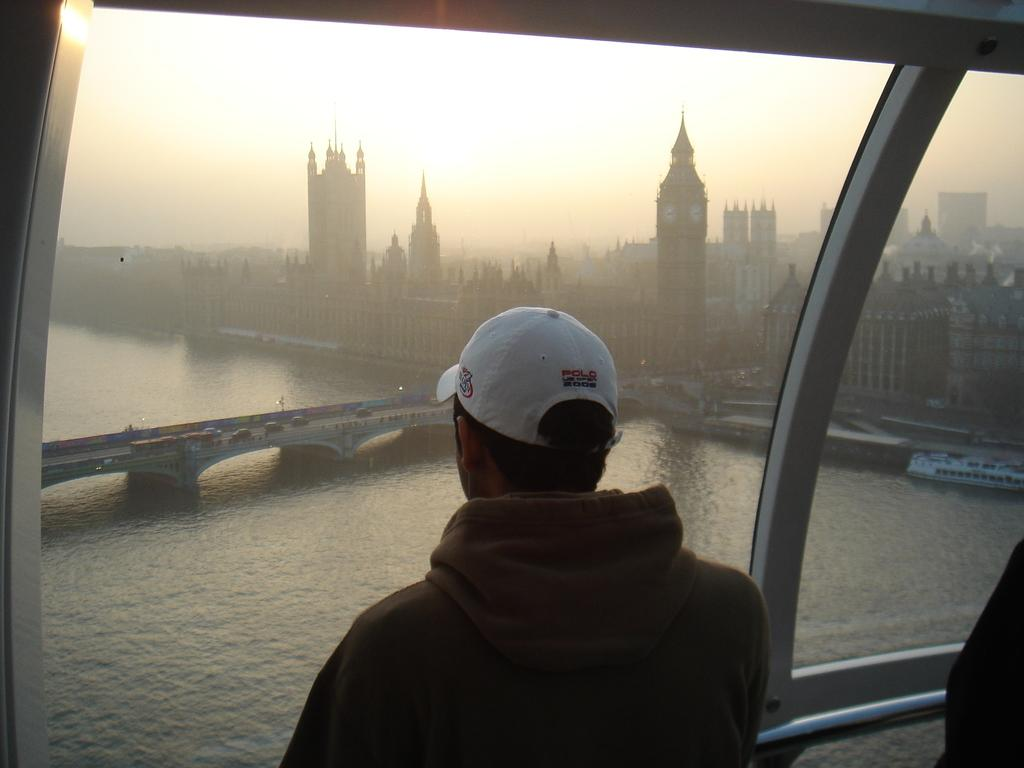What is the main structure in the middle of the image? There is a building in the middle of the image. What other feature is present in the middle of the image? There is a bridge in the middle of the image. Are there any people visible in the image? Yes, there are people standing in the middle of the image. What can be seen at the top of the image? The sky is visible at the top of the image. What type of gold object can be seen on the bridge in the image? There is no gold object present on the bridge in the image. What attempt is being made by the people standing in the middle of the image? There is no indication of any attempt being made by the people in the image. --- Facts: 1. There is a car in the image. 2. The car is red. 3. The car has four wheels. 4. There is a road in the image. 5. The road is paved. Absurd Topics: bird, dance, ocean Conversation: What is the main subject of the image? The main subject of the image is a car. What color is the car? The car is red. How many wheels does the car have? The car has four wheels. What type of surface is the car on? There is a road in the image, and it is paved. Reasoning: Let's think step by step in order to produce the conversation. We start by identifying the main subject of the image, which is the car. Then, we describe specific features of the car, such as its color and the number of wheels. Next, we observe the setting in which the car is located, noting that it is on a paved road. Each question is designed to elicit a specific detail about the image that is known from the provided facts. Absurd Question/Answer: What type of bird can be seen flying over the ocean in the image? There is no bird or ocean present in the image. 